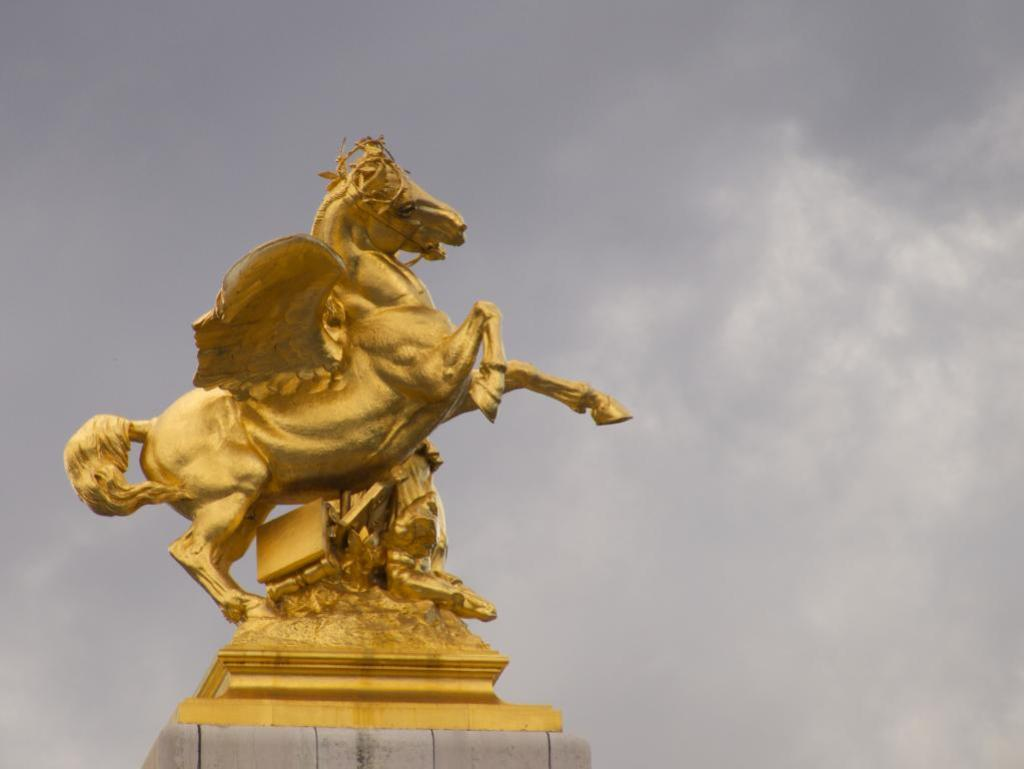What is the main subject in the center of the image? There is a statue in the center of the image. What can be seen in the background of the image? There is sky visible in the background of the image. Are there any additional features in the background? Yes, there are clouds in the background of the image. What book is the statue holding in the image? There is no book present in the image; the statue is not holding anything. 